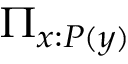Convert formula to latex. <formula><loc_0><loc_0><loc_500><loc_500>\Pi _ { x \colon P ( y ) }</formula> 